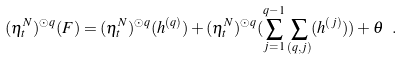Convert formula to latex. <formula><loc_0><loc_0><loc_500><loc_500>( \eta _ { t } ^ { N } ) ^ { \odot q } ( F ) = ( \eta _ { t } ^ { N } ) ^ { \odot q } ( h ^ { ( q ) } ) + ( \eta _ { t } ^ { N } ) ^ { \odot q } ( \sum _ { j = 1 } ^ { q - 1 } \sum _ { ( q , j ) } ( h ^ { ( j ) } ) ) + \theta \ .</formula> 